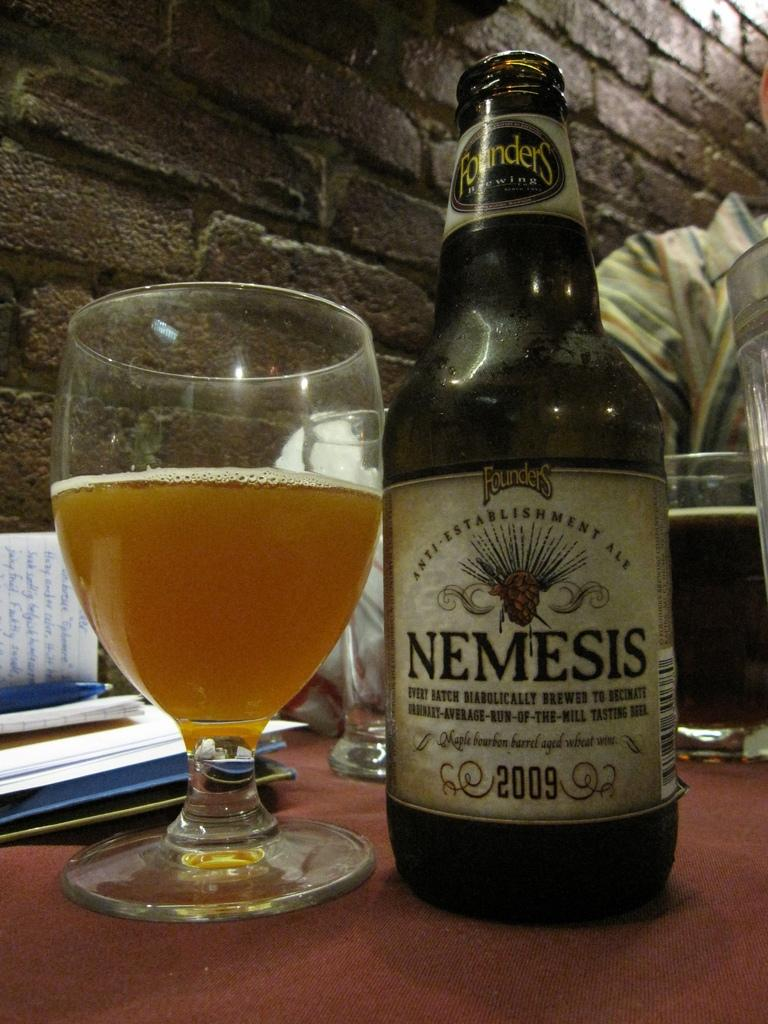<image>
Create a compact narrative representing the image presented. A bottle of Nemesis brand "Maple bourbon barrel aged wheat wine" is shown next to a glass. 